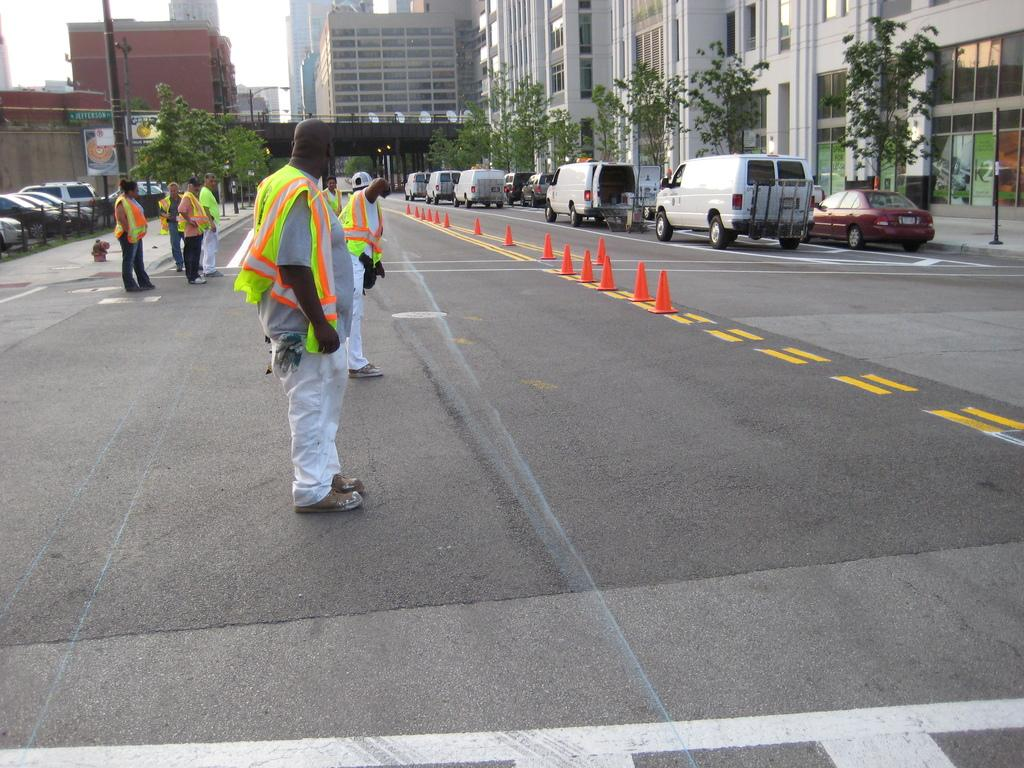Who or what can be seen in the image? There are people in the image. What objects are present on the road in the image? There are traffic cones and cars on the road in the image. What type of structures are visible in the image? There are buildings in the image. What natural elements can be seen in the image? There are trees in the image. What else can be seen in the image besides the people, cars, and buildings? There are poles in the image. Can you hear the bell ringing in the image? There is no bell present in the image, so it cannot be heard. 